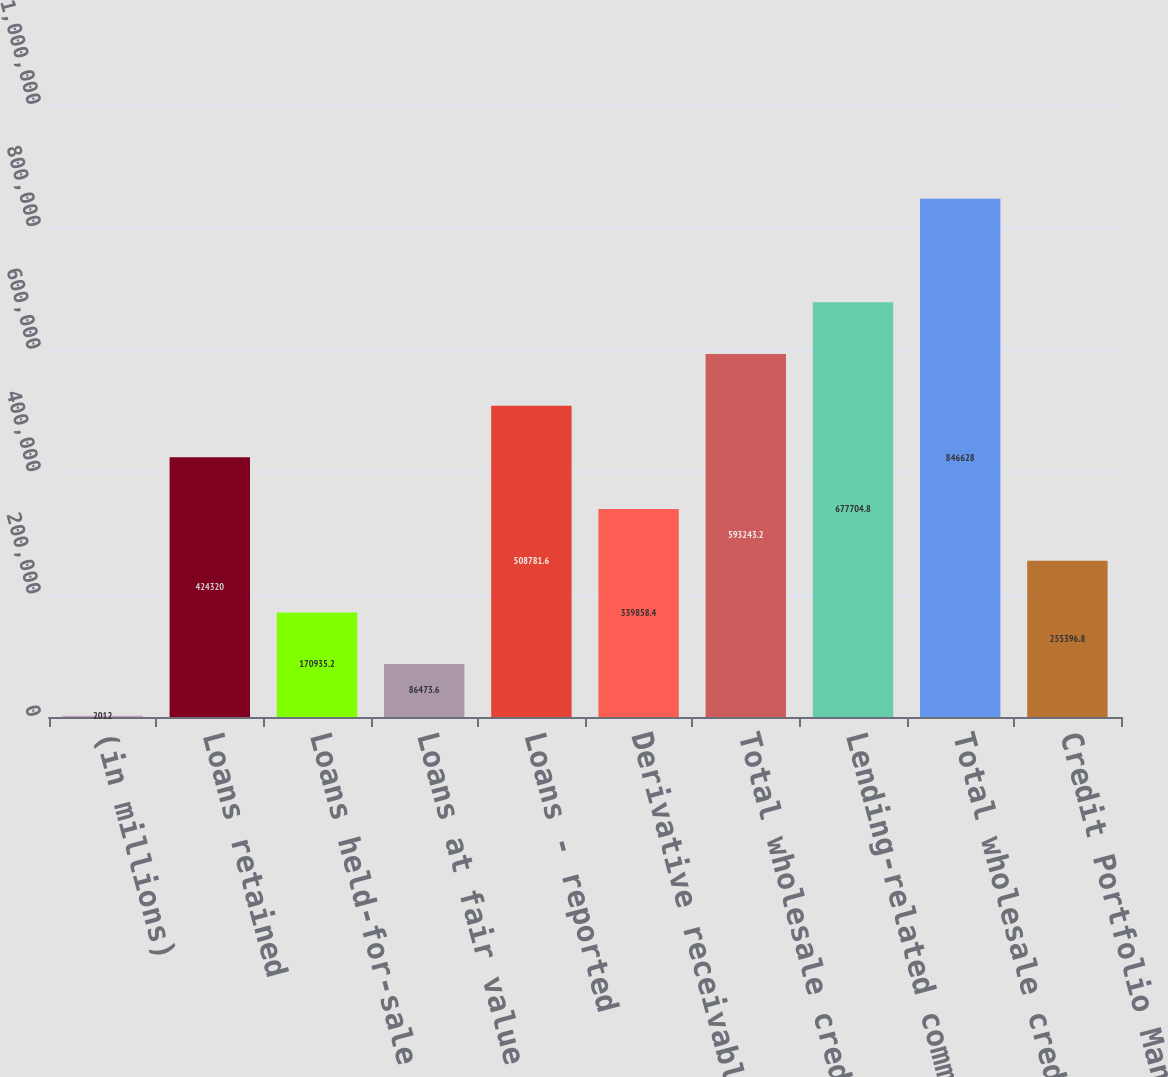<chart> <loc_0><loc_0><loc_500><loc_500><bar_chart><fcel>(in millions)<fcel>Loans retained<fcel>Loans held-for-sale<fcel>Loans at fair value<fcel>Loans - reported<fcel>Derivative receivables<fcel>Total wholesale credit-<fcel>Lending-related commitments<fcel>Total wholesale credit<fcel>Credit Portfolio Management<nl><fcel>2012<fcel>424320<fcel>170935<fcel>86473.6<fcel>508782<fcel>339858<fcel>593243<fcel>677705<fcel>846628<fcel>255397<nl></chart> 